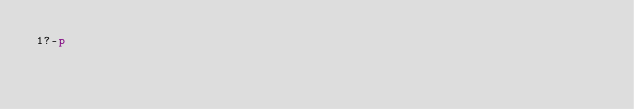Convert code to text. <code><loc_0><loc_0><loc_500><loc_500><_dc_>1?-p</code> 